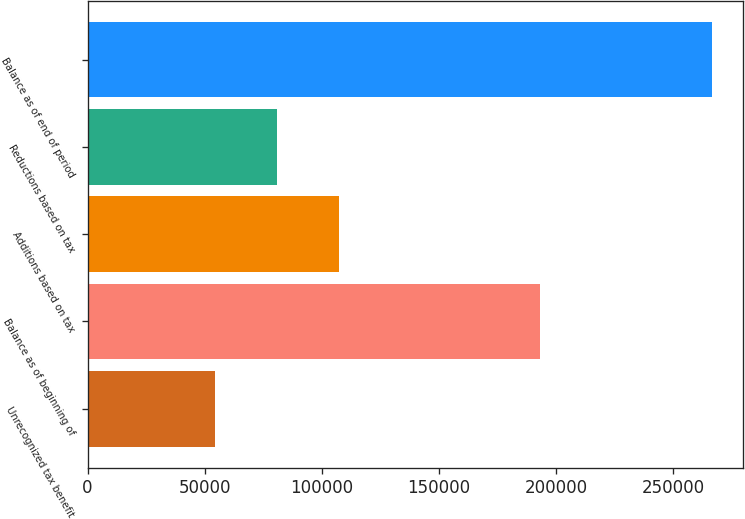Convert chart to OTSL. <chart><loc_0><loc_0><loc_500><loc_500><bar_chart><fcel>Unrecognized tax benefit<fcel>Balance as of beginning of<fcel>Additions based on tax<fcel>Reductions based on tax<fcel>Balance as of end of period<nl><fcel>54275.8<fcel>193320<fcel>107383<fcel>80829.2<fcel>266703<nl></chart> 